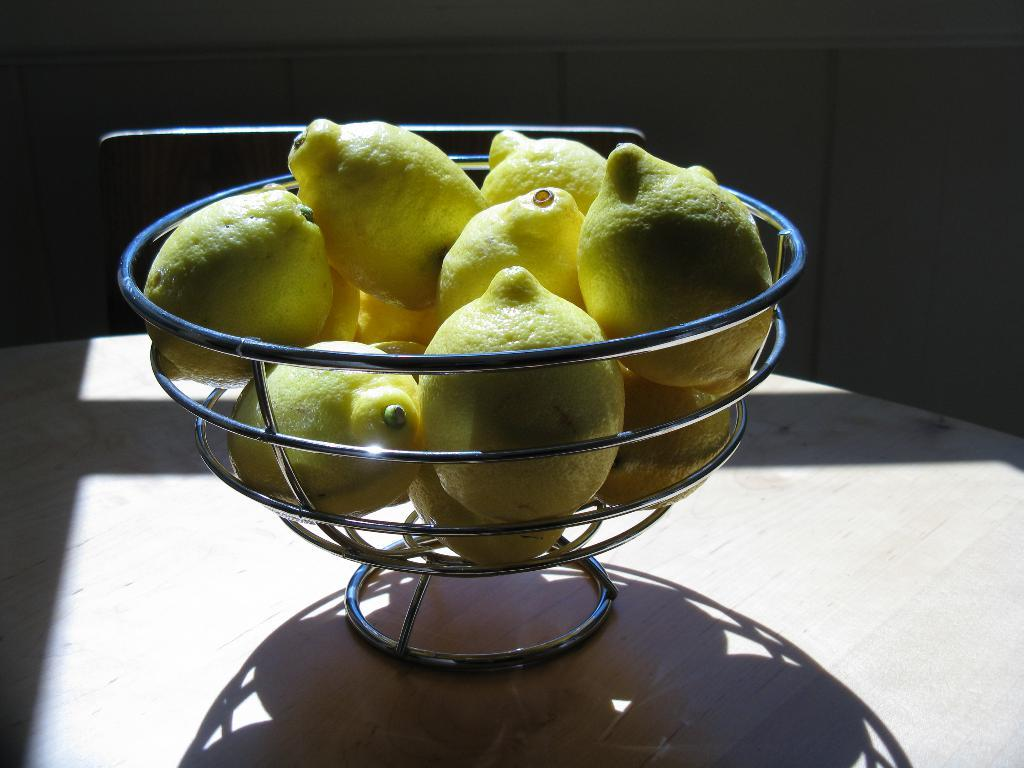What type of fruit is in the bowl in the image? There are lemons in a bowl in the image. Where is the bowl of lemons located? The bowl is placed on a table. What can be seen in the background of the image? There is a wall in the background of the image. What type of instrument is being played on the dock in the image? There is no dock or instrument present in the image; it only features a bowl of lemons on a table with a wall in the background. 